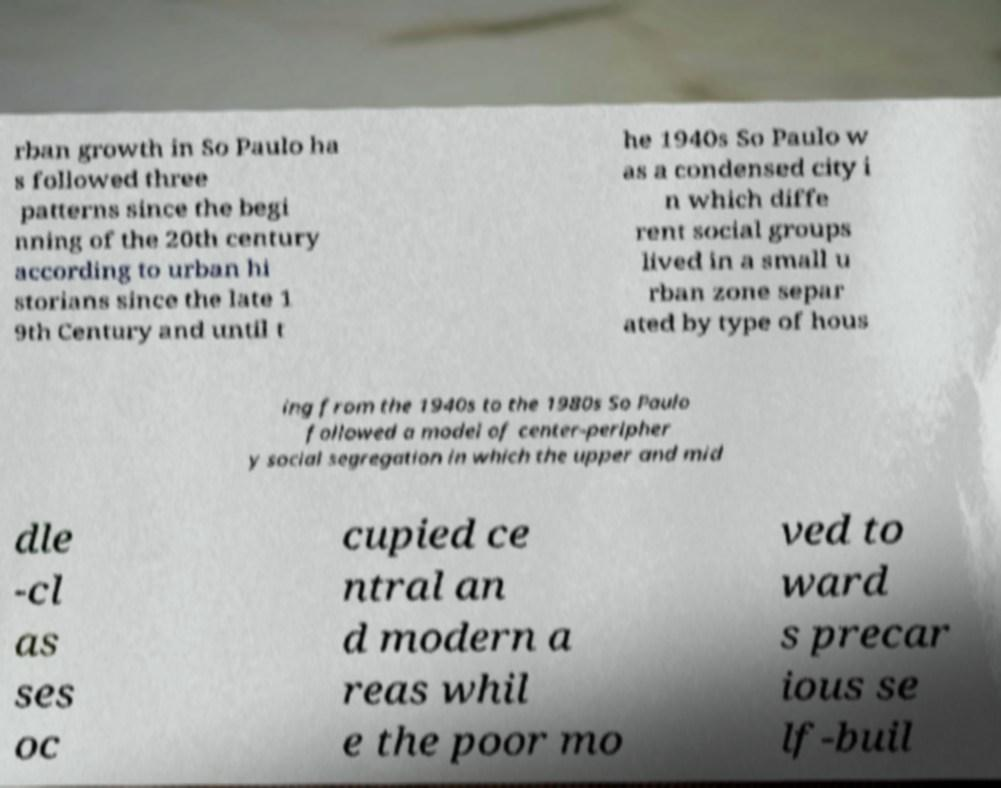There's text embedded in this image that I need extracted. Can you transcribe it verbatim? rban growth in So Paulo ha s followed three patterns since the begi nning of the 20th century according to urban hi storians since the late 1 9th Century and until t he 1940s So Paulo w as a condensed city i n which diffe rent social groups lived in a small u rban zone separ ated by type of hous ing from the 1940s to the 1980s So Paulo followed a model of center-peripher y social segregation in which the upper and mid dle -cl as ses oc cupied ce ntral an d modern a reas whil e the poor mo ved to ward s precar ious se lf-buil 